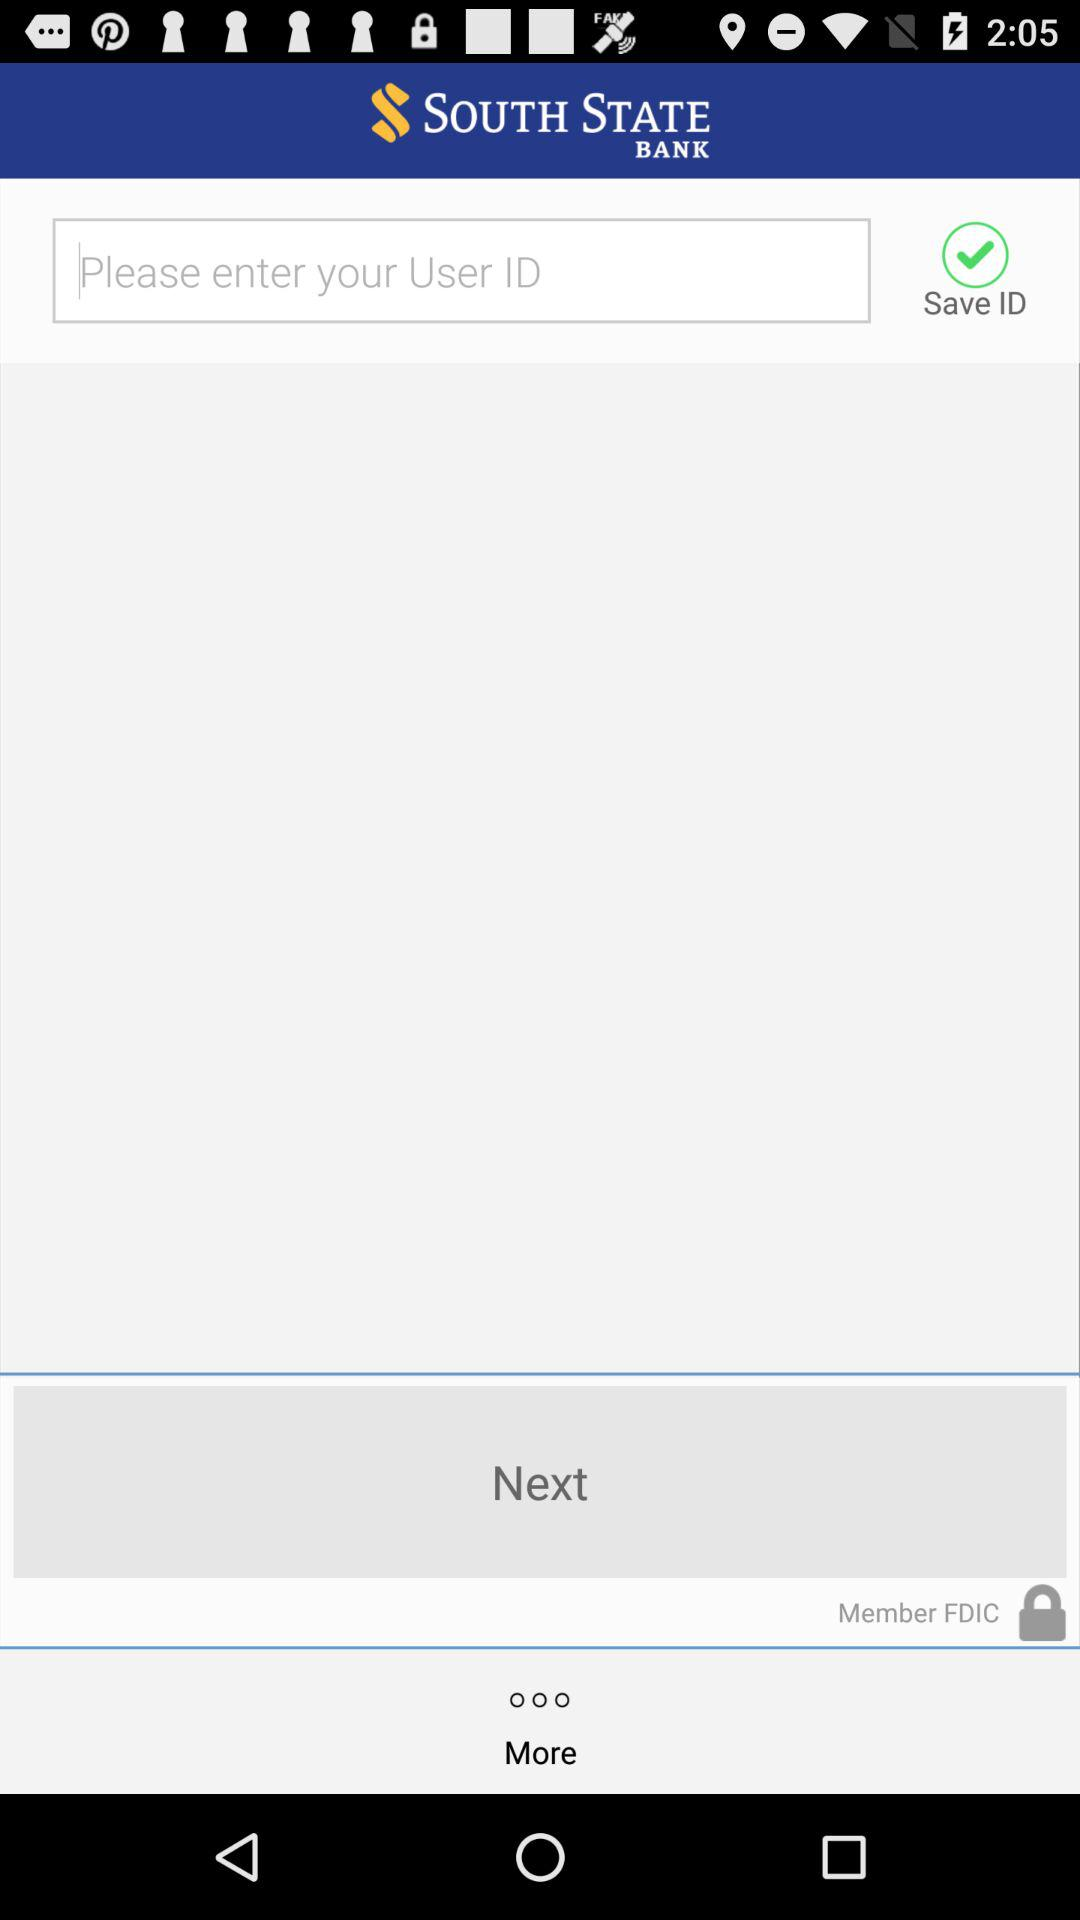What is the app name? The app name is "South State Mobile Banking". 